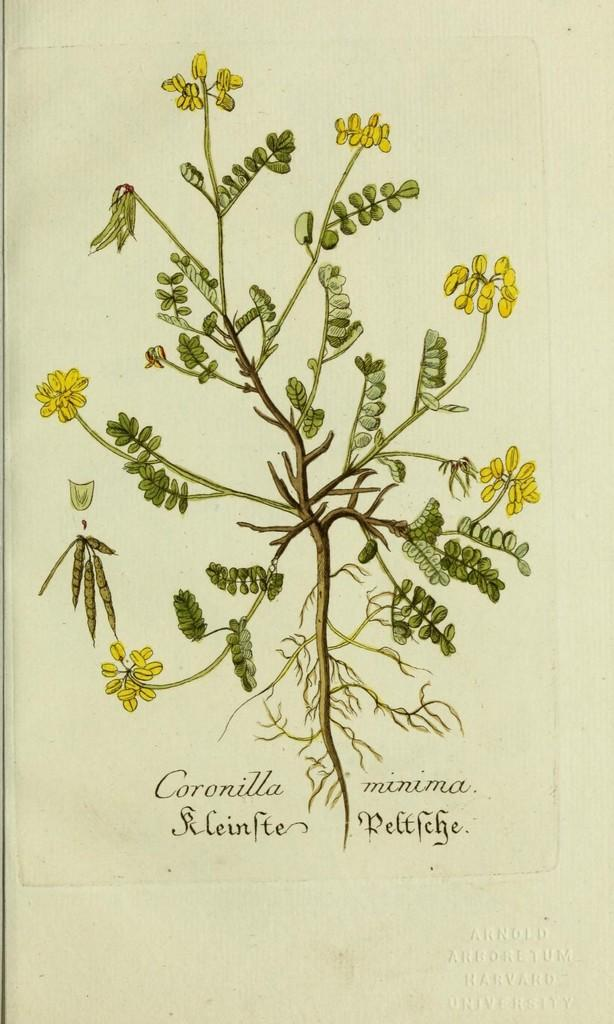What is present on the paper in the image? The paper contains a sketch. What does the sketch depict? The sketch depicts branches, leaves, flowers, and roots of a plant. What type of rock can be seen burning in the image? There is no rock or burning element present in the image; it features a paper with a sketch of a plant. 